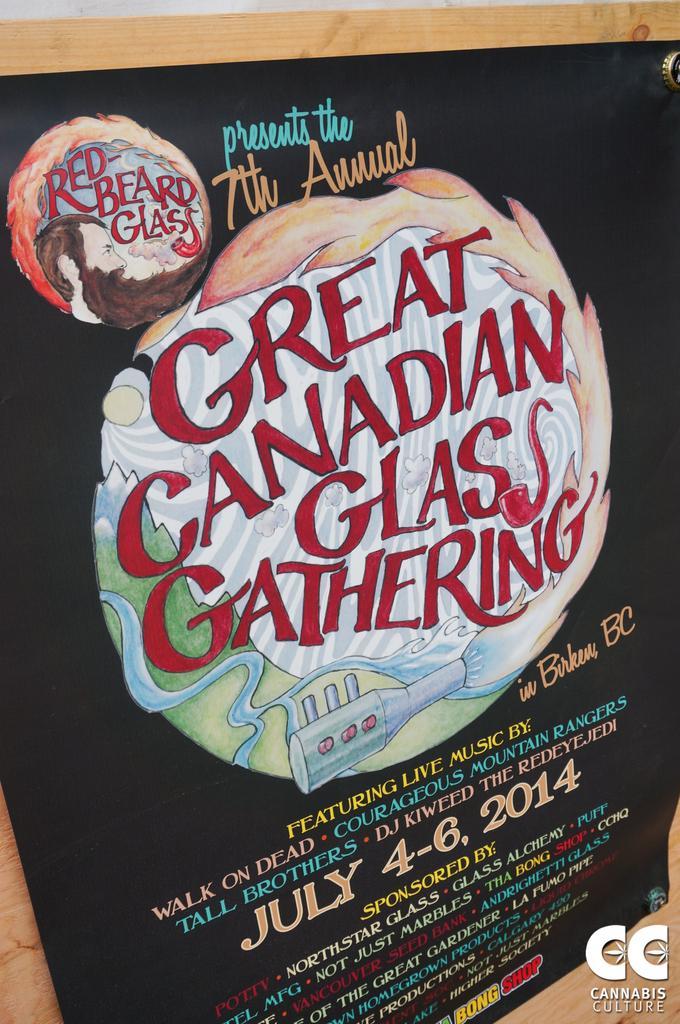Describe this image in one or two sentences. In this image I can see a blackboard with some text written on it. 